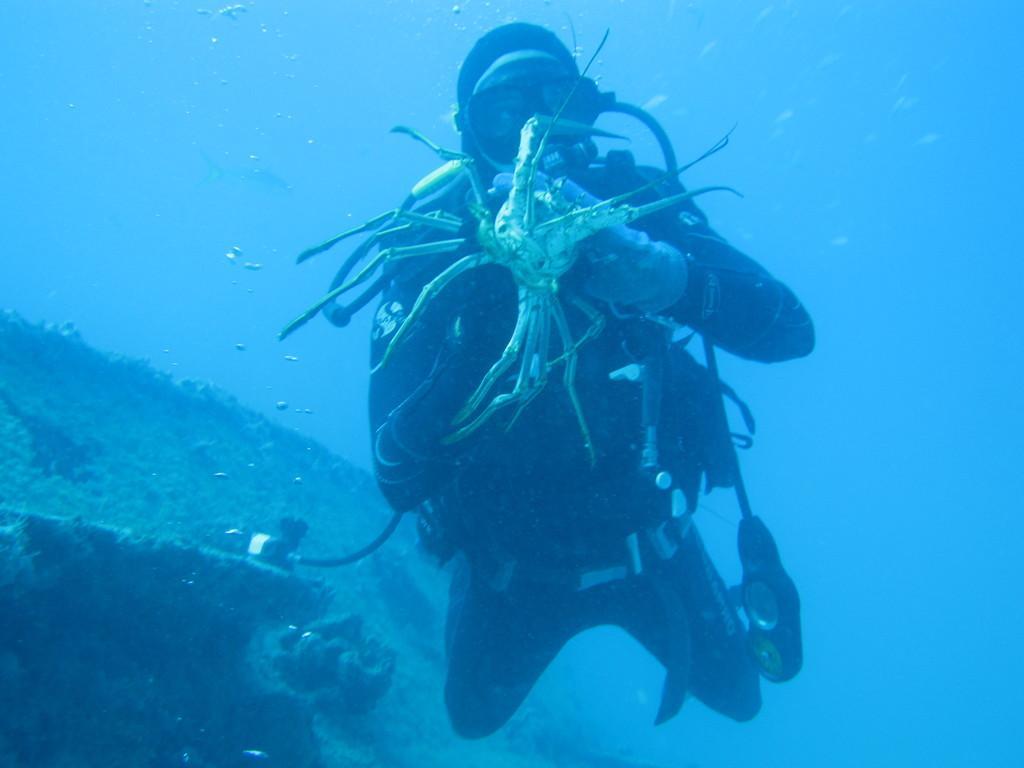Could you give a brief overview of what you see in this image? This is an image clicked inside the water. Here I can see a person wearing costume and diving and this person is holding a crab. In the background, I can see few marine species. 